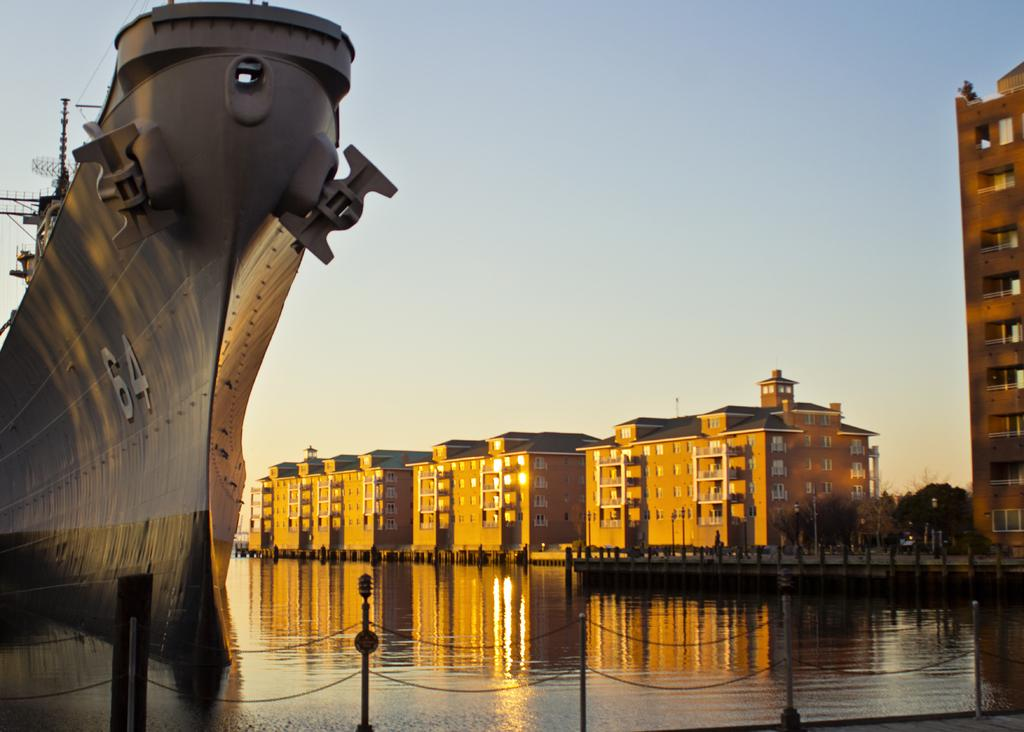What is the main subject of the image? There is a ship on the water. What can be seen near the ship? There is a fencing near the ship. What is visible in the background of the image? There are trees and buildings in the background. How many tomatoes are hanging from the wire in the image? There is no wire or tomatoes present in the image. 